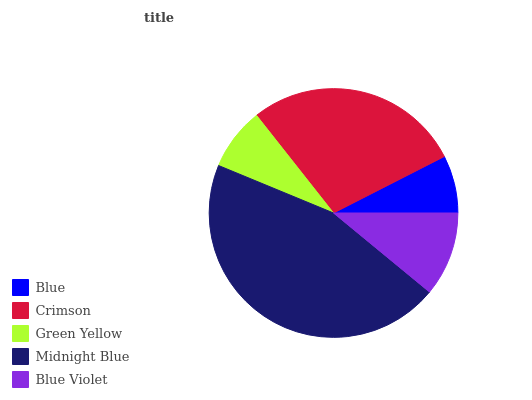Is Blue the minimum?
Answer yes or no. Yes. Is Midnight Blue the maximum?
Answer yes or no. Yes. Is Crimson the minimum?
Answer yes or no. No. Is Crimson the maximum?
Answer yes or no. No. Is Crimson greater than Blue?
Answer yes or no. Yes. Is Blue less than Crimson?
Answer yes or no. Yes. Is Blue greater than Crimson?
Answer yes or no. No. Is Crimson less than Blue?
Answer yes or no. No. Is Blue Violet the high median?
Answer yes or no. Yes. Is Blue Violet the low median?
Answer yes or no. Yes. Is Crimson the high median?
Answer yes or no. No. Is Midnight Blue the low median?
Answer yes or no. No. 